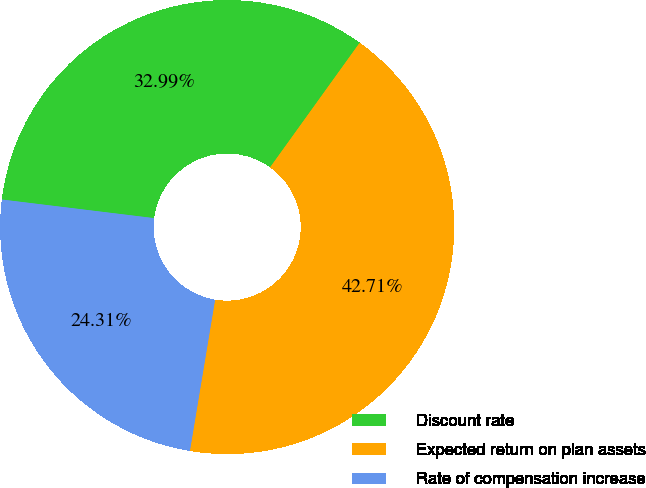<chart> <loc_0><loc_0><loc_500><loc_500><pie_chart><fcel>Discount rate<fcel>Expected return on plan assets<fcel>Rate of compensation increase<nl><fcel>32.99%<fcel>42.71%<fcel>24.31%<nl></chart> 